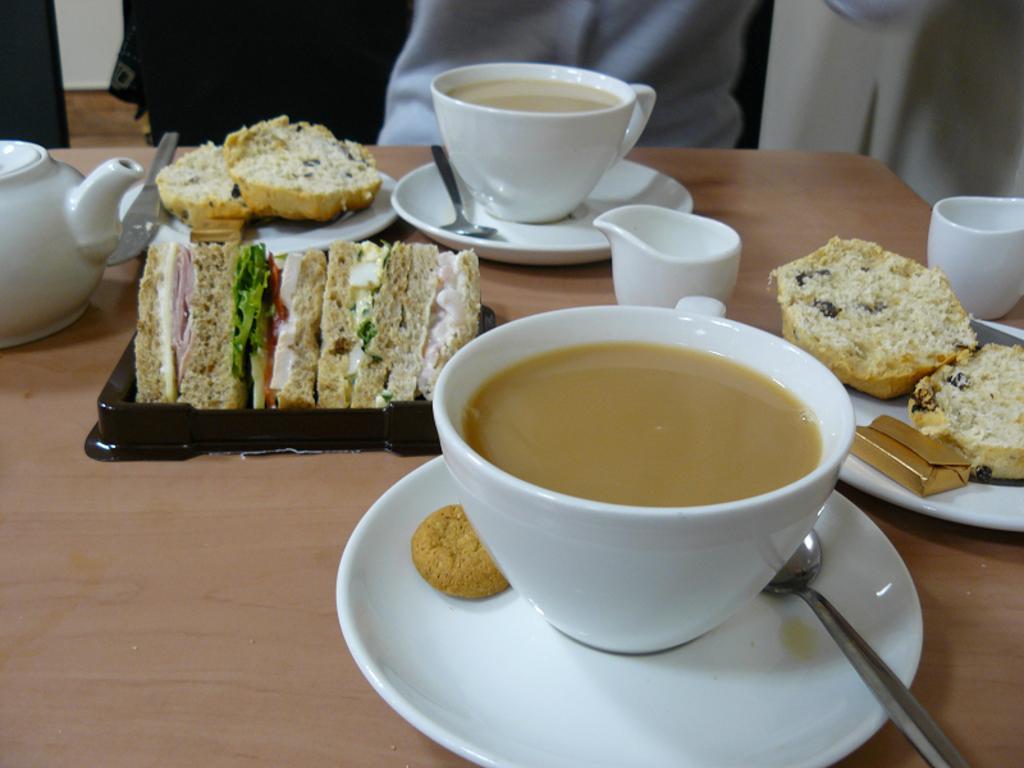Can you describe this image briefly? In this image I see the brown color surface on which there are 2 cups and 2 saucers and I see 2 plates on which there is food which is of white and cream in color and I see food on this black color thing and I see 2 spoons and I see a kettle over here. 